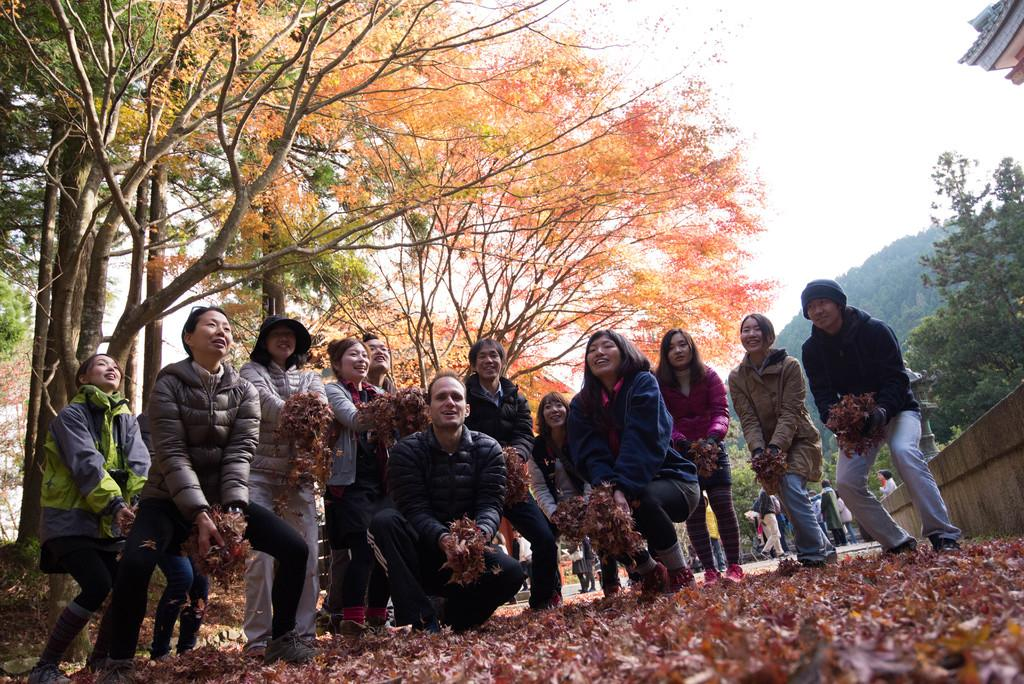What is happening in the image involving a group of people? There is a group of people in the image, and they are standing on the floor. What are the people holding in the image? The people are holding leaves in the image. What else can be seen on the floor in the image? There are leaves on the floor in the image. What can be seen in the background of the image? There are trees in the background of the image. What type of button is being used to hold the leaves together in the image? There is no button present in the image; the people are simply holding the leaves. 